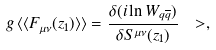Convert formula to latex. <formula><loc_0><loc_0><loc_500><loc_500>g \, \langle \langle F _ { \mu \nu } ( z _ { 1 } ) \rangle \rangle = \frac { \delta ( i \ln W _ { q \overline { q } } ) } { \delta S ^ { \mu \nu } ( z _ { 1 } ) } \ > ,</formula> 